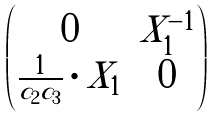Convert formula to latex. <formula><loc_0><loc_0><loc_500><loc_500>\begin{pmatrix} 0 & X _ { 1 } ^ { - 1 } \\ \frac { 1 } { c _ { 2 } c _ { 3 } } \cdot X _ { 1 } & 0 \end{pmatrix}</formula> 